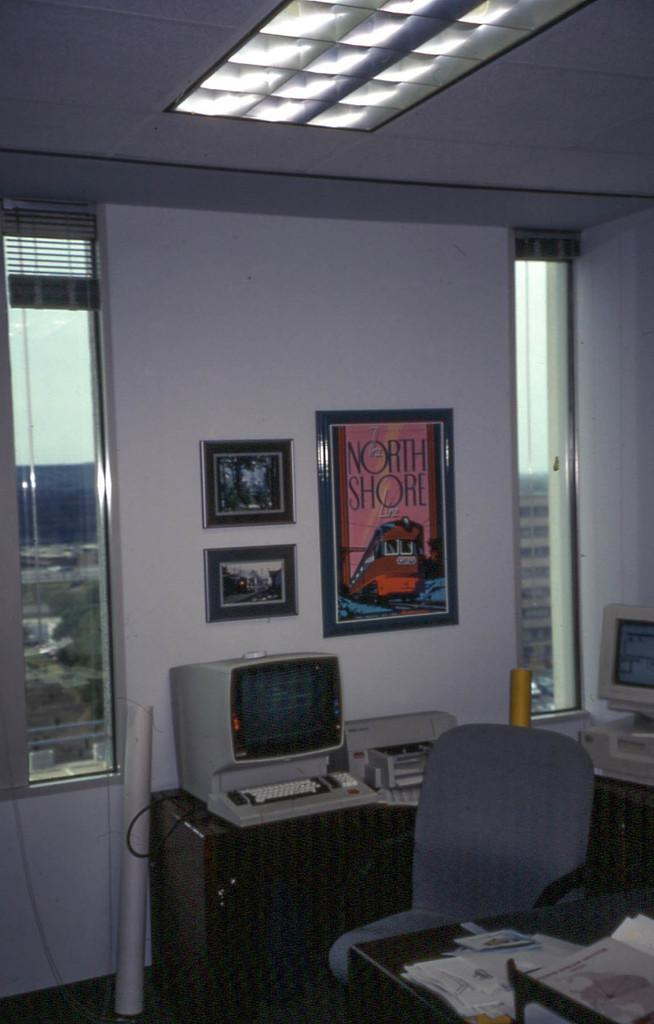Provide a one-sentence caption for the provided image. a poster with North Shore written on it. 